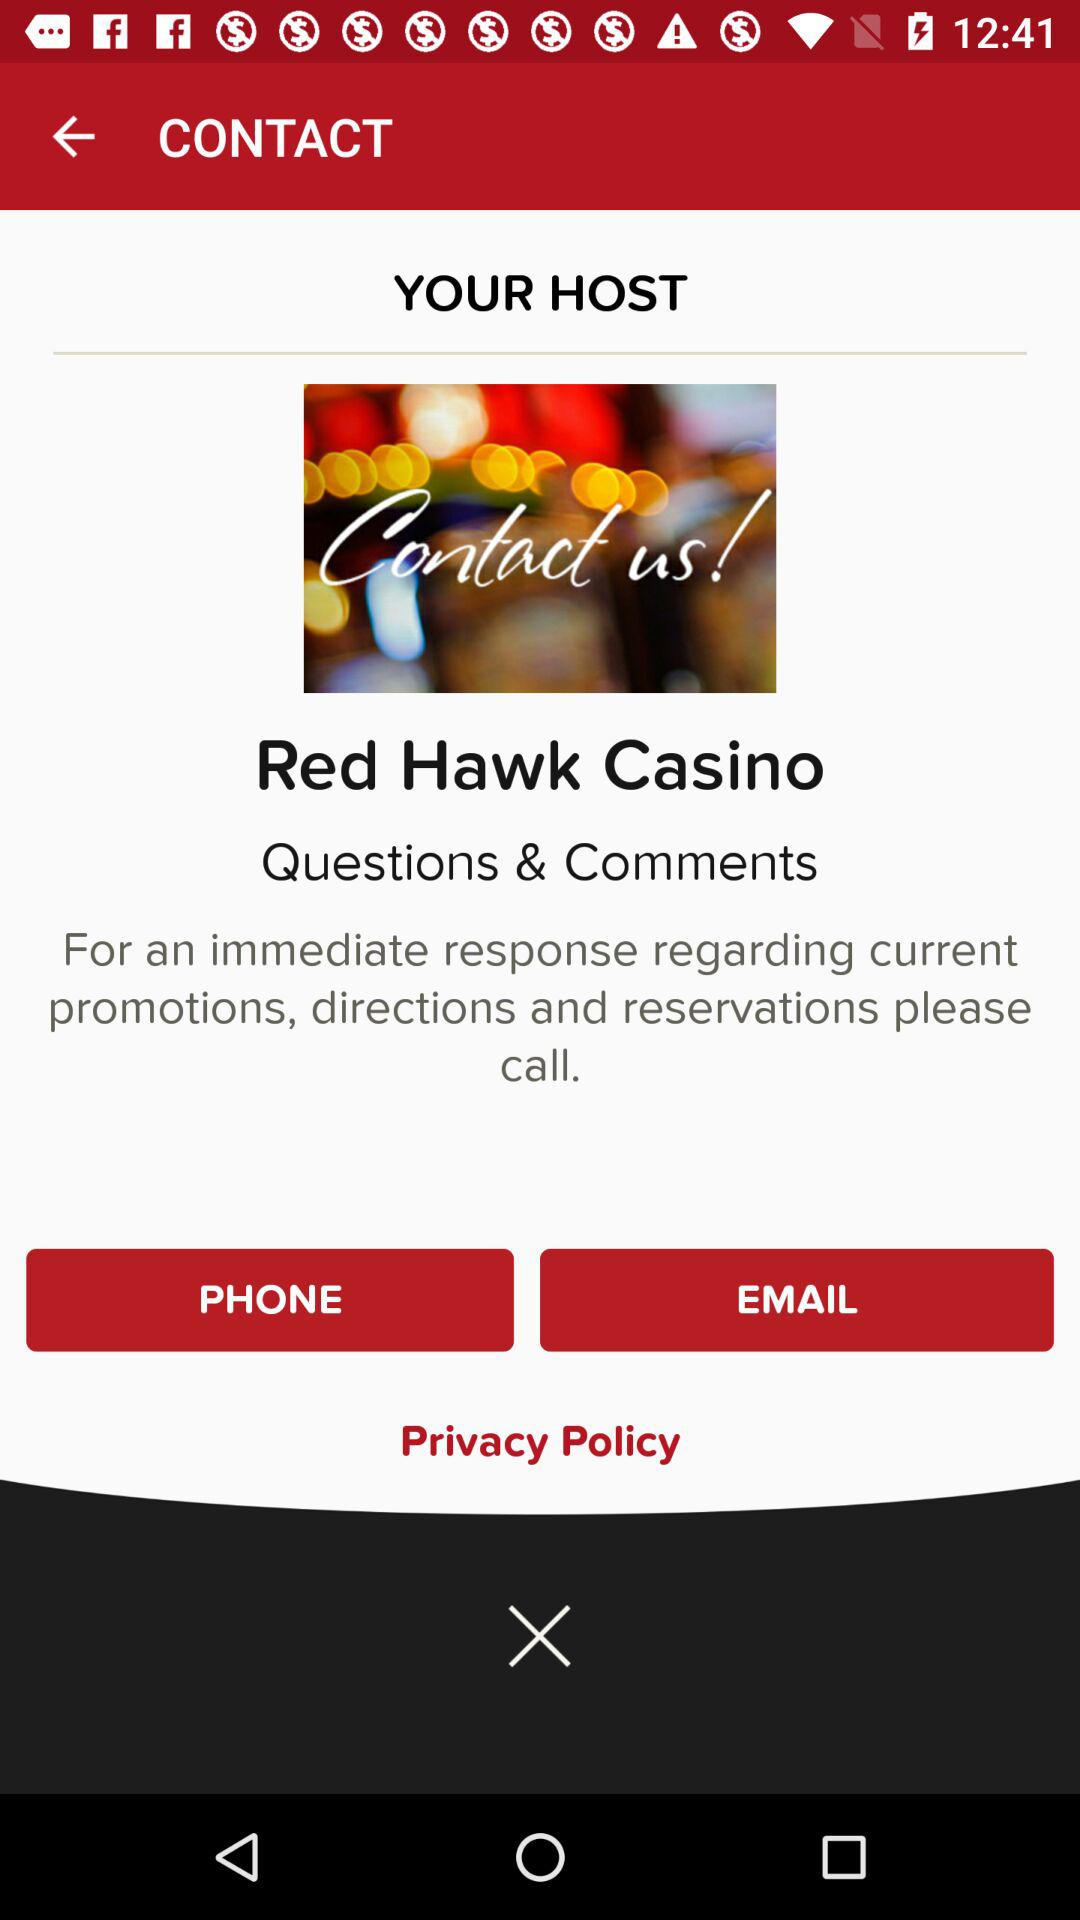What is the name of the casino? The name of the casino is "Red Hawk Casino". 